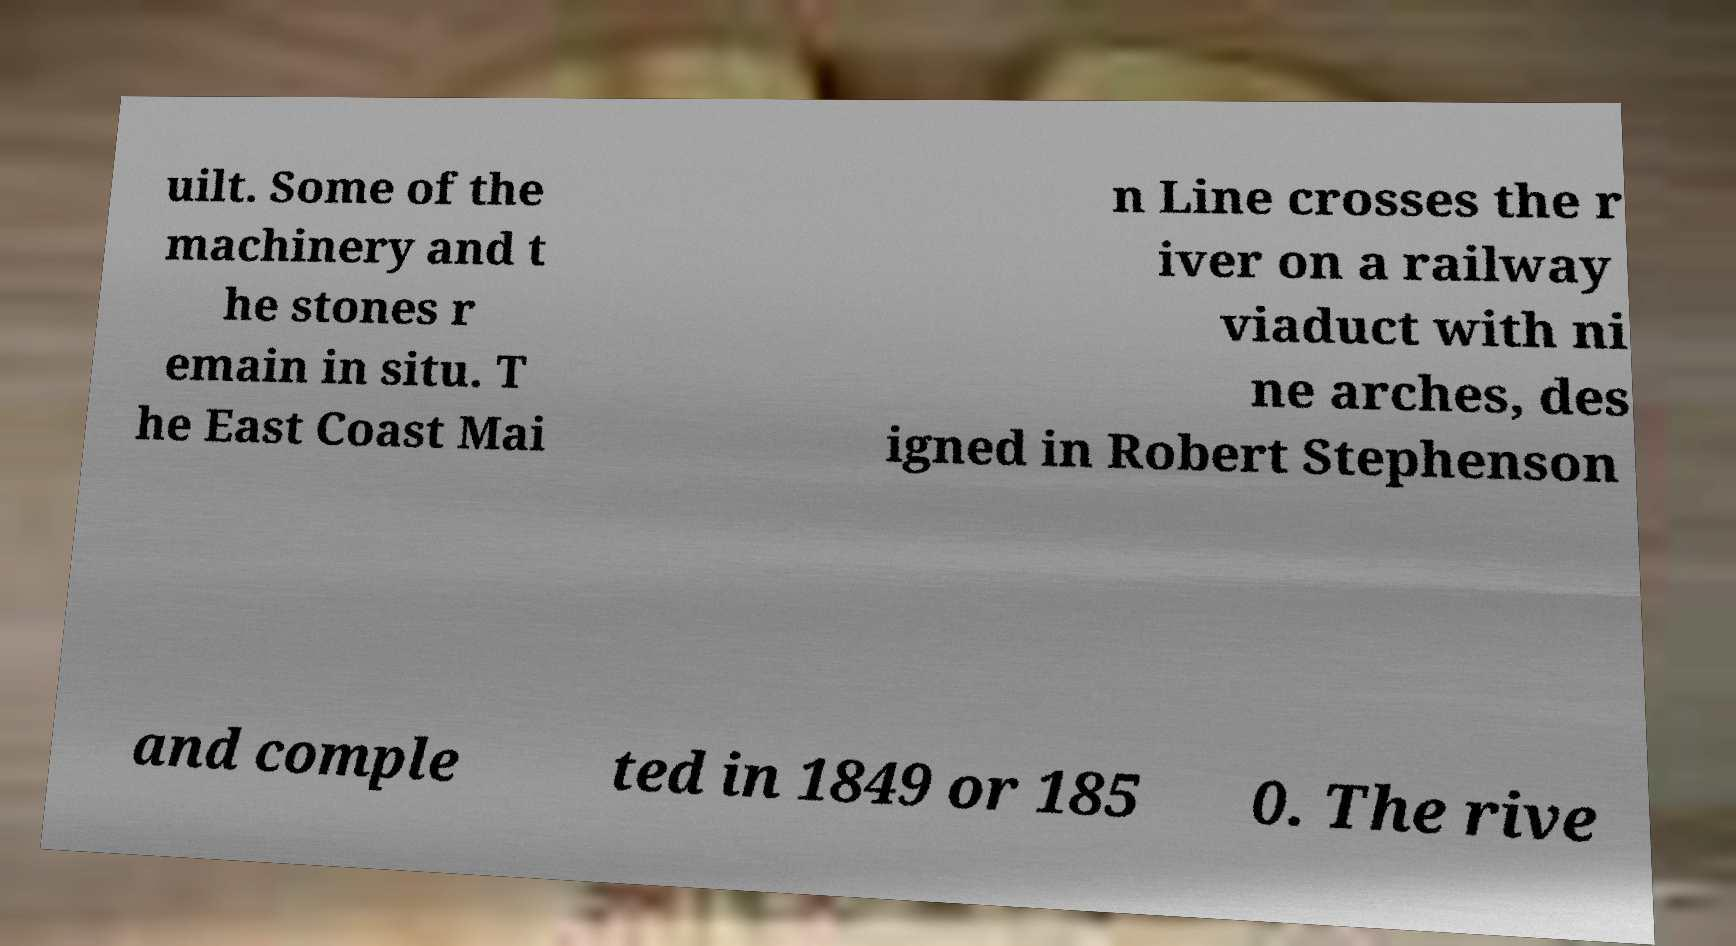What messages or text are displayed in this image? I need them in a readable, typed format. uilt. Some of the machinery and t he stones r emain in situ. T he East Coast Mai n Line crosses the r iver on a railway viaduct with ni ne arches, des igned in Robert Stephenson and comple ted in 1849 or 185 0. The rive 